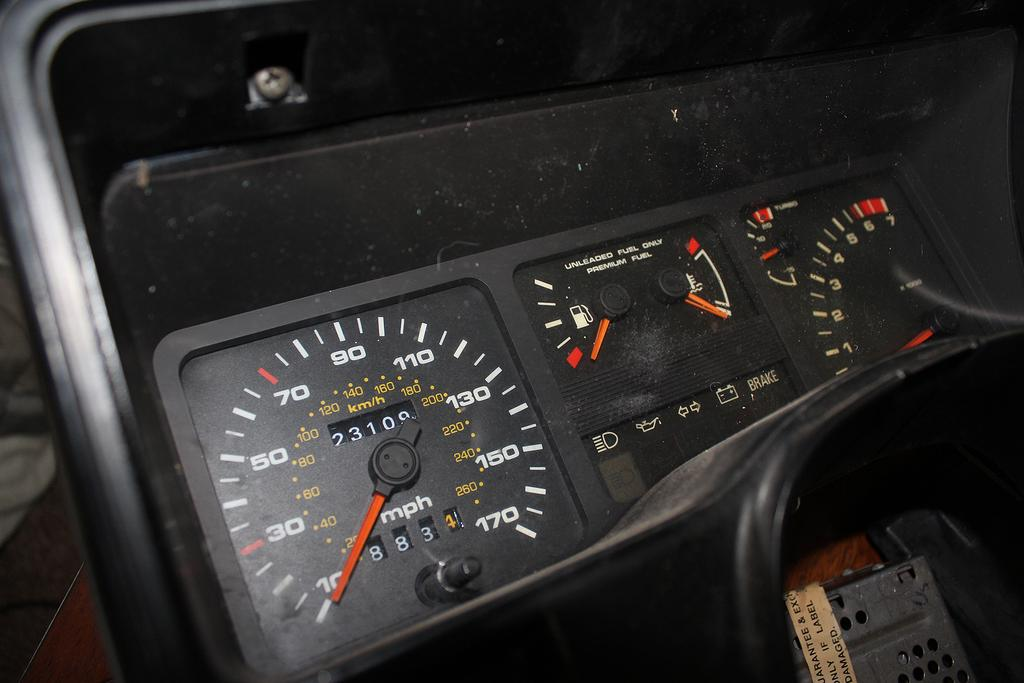What can be seen in the image? There is a meter reading in the image. What type of information might the meter reading provide? The meter reading could provide information about the usage or consumption of a particular resource, such as electricity or water. How might the meter reading be used? The meter reading might be used for billing purposes or to monitor and manage resource consumption. What type of knowledge is being discussed in the image? There is no discussion or knowledge being presented in the image; it simply shows a meter reading. 